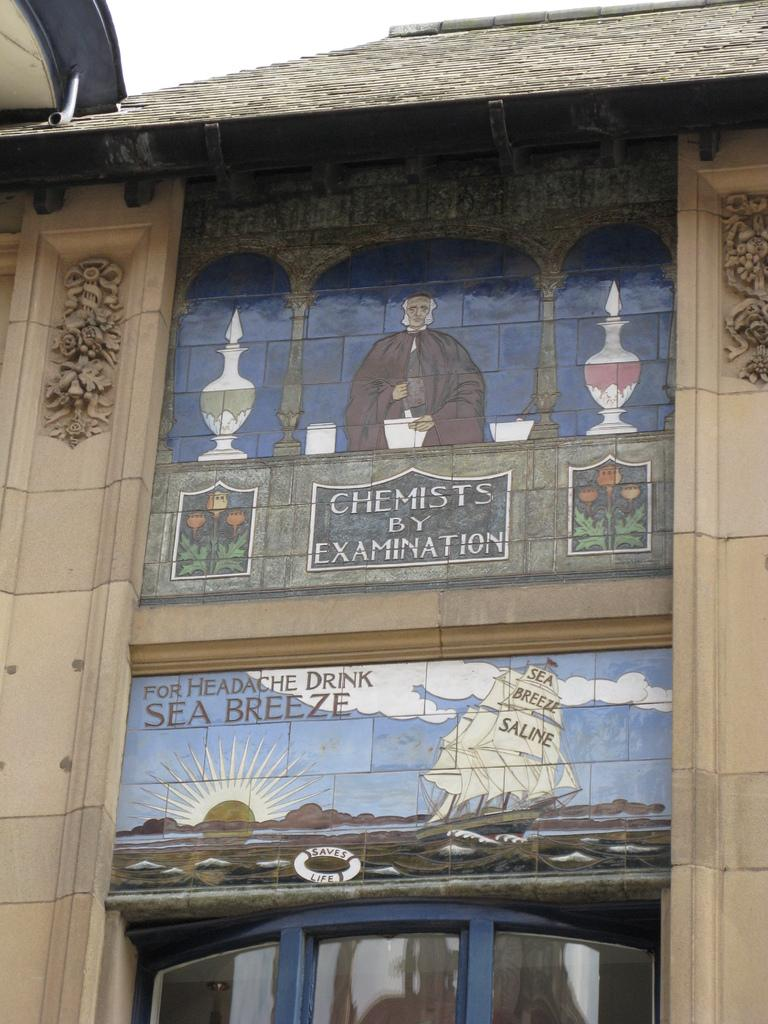What is the main subject of the picture? The main subject of the picture is a building. What feature of the building is mentioned in the facts? The building has a picture of a man. What can be seen on the picture of the man? There is something written on the picture. How would you describe the weather based on the image? The sky is clear in the image. Can you tell me how many blades are attached to the building in the image? There are no blades mentioned or visible in the image; the main focus is on the building and the picture of a man. 